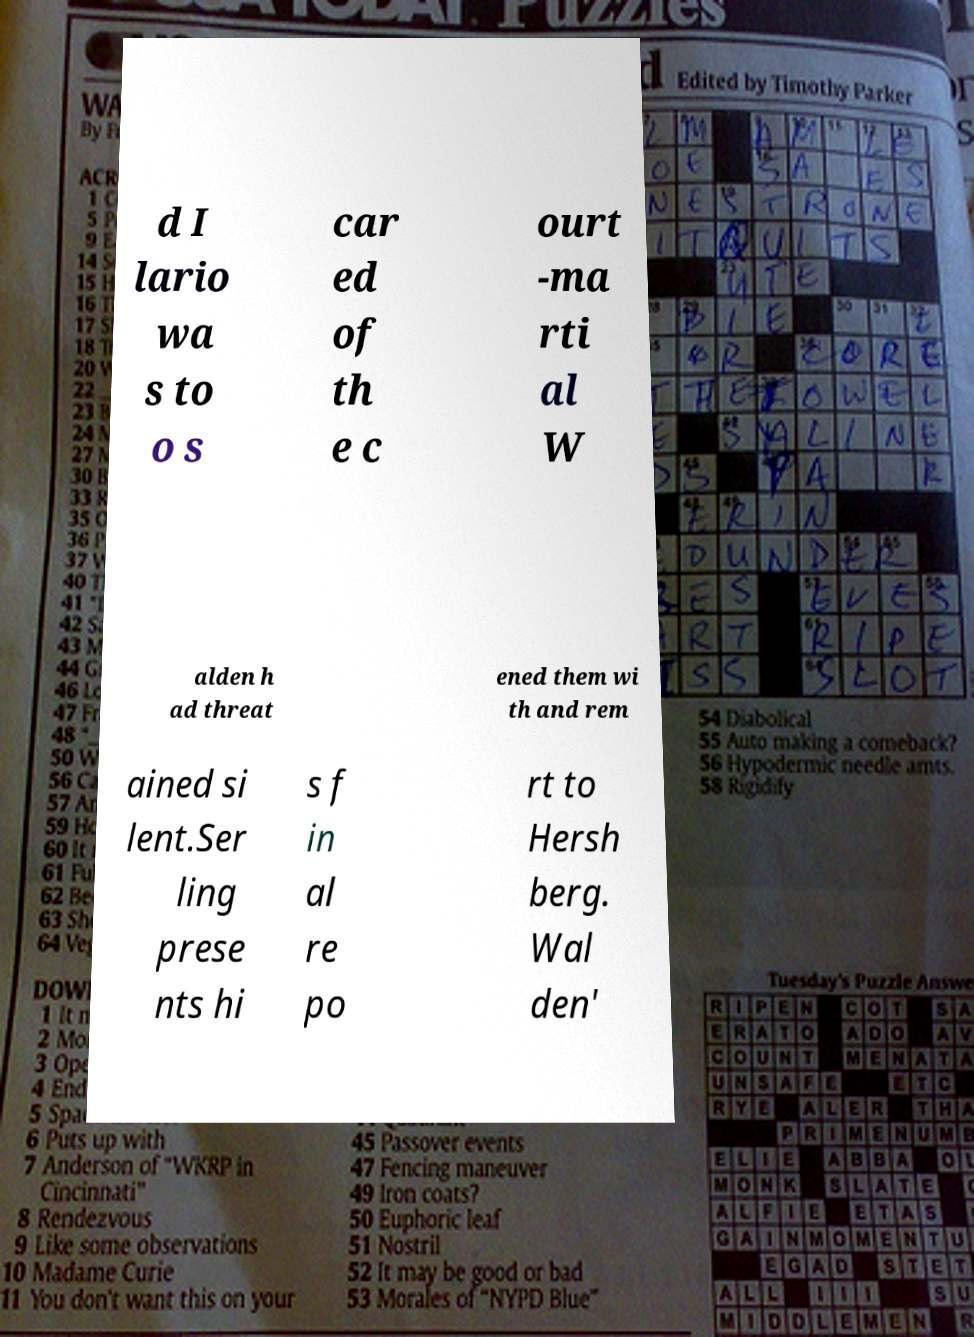Could you assist in decoding the text presented in this image and type it out clearly? d I lario wa s to o s car ed of th e c ourt -ma rti al W alden h ad threat ened them wi th and rem ained si lent.Ser ling prese nts hi s f in al re po rt to Hersh berg. Wal den' 